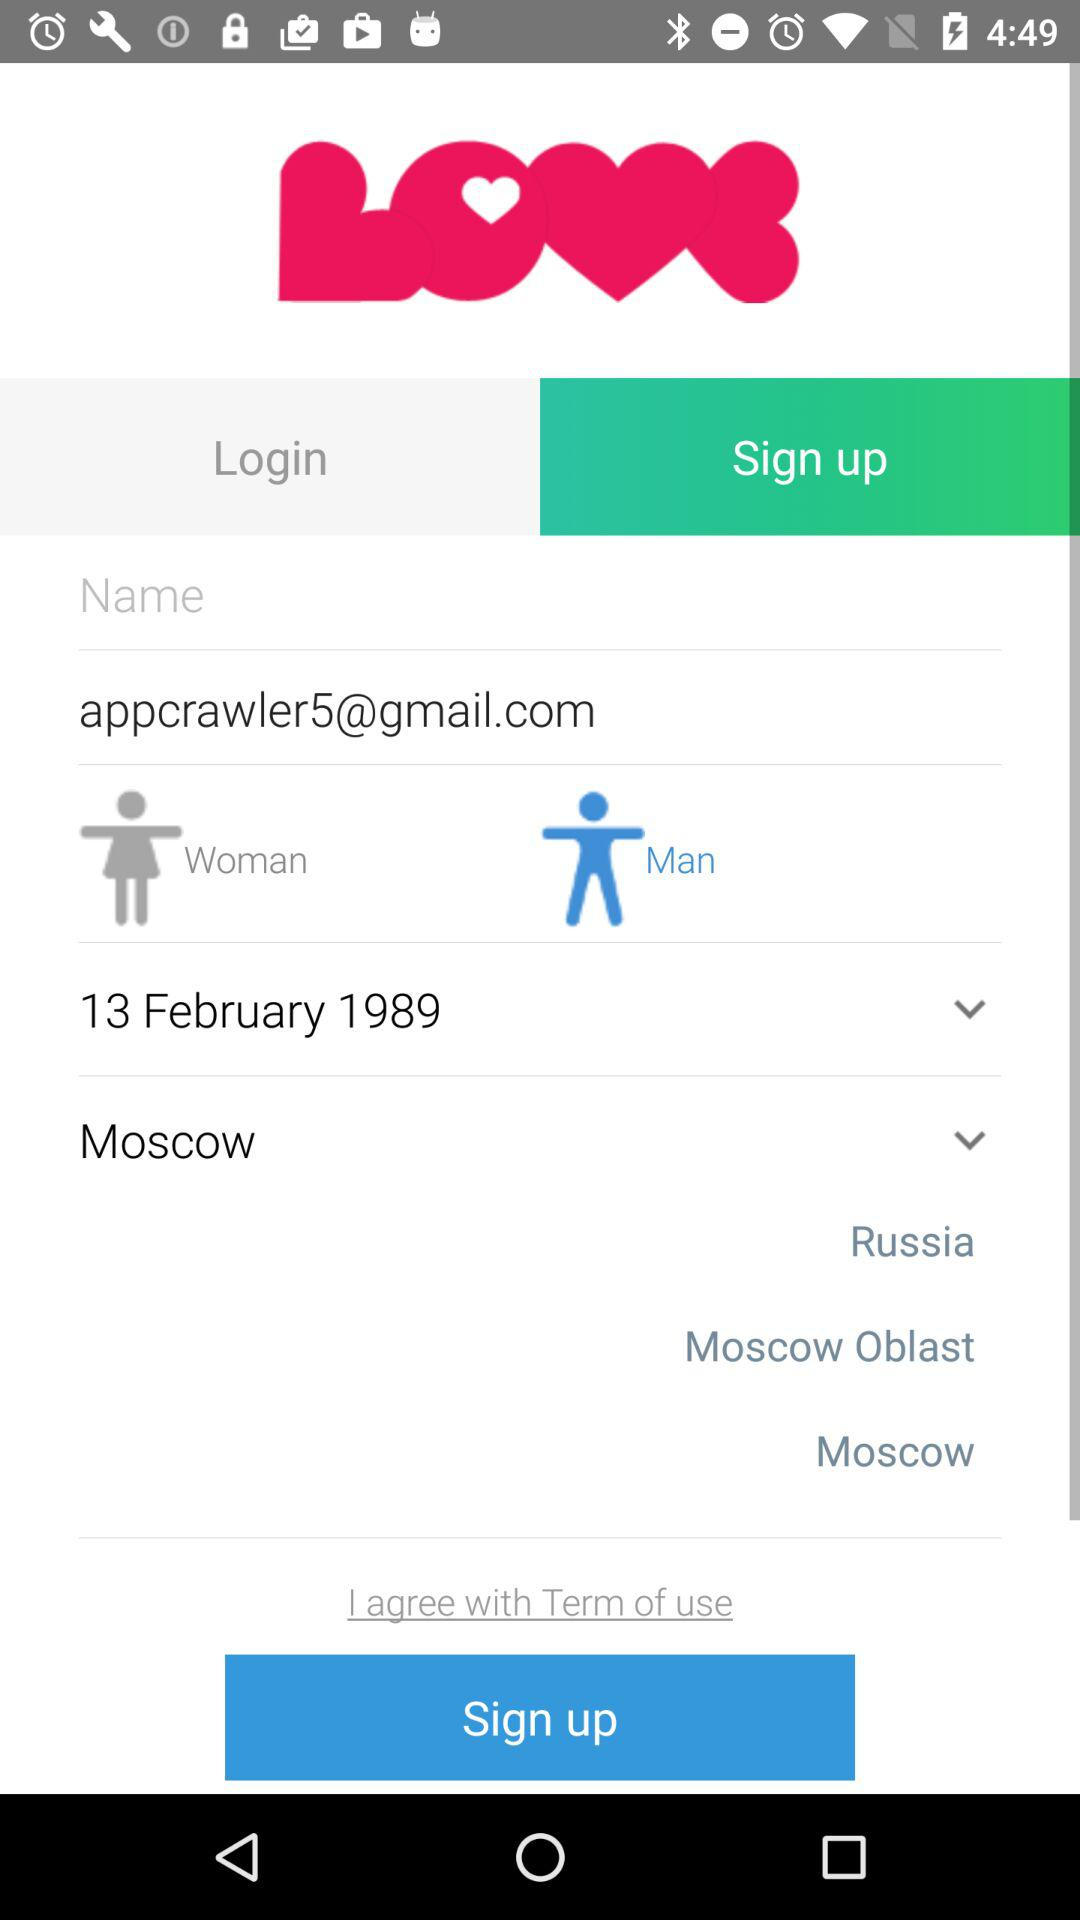How many options are there for country?
Answer the question using a single word or phrase. 3 